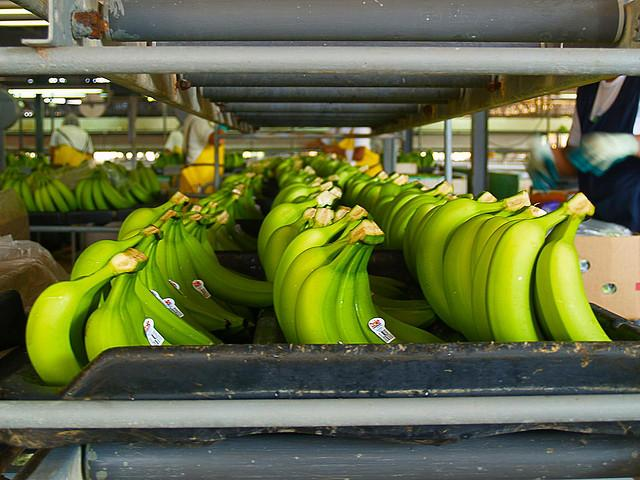Which food company produces these bananas? Please explain your reasoning. dole. Each banana has a sticker that contains this company's name. 